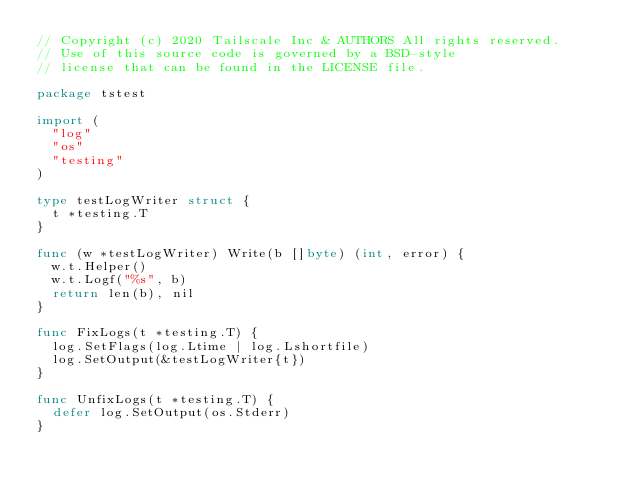<code> <loc_0><loc_0><loc_500><loc_500><_Go_>// Copyright (c) 2020 Tailscale Inc & AUTHORS All rights reserved.
// Use of this source code is governed by a BSD-style
// license that can be found in the LICENSE file.

package tstest

import (
	"log"
	"os"
	"testing"
)

type testLogWriter struct {
	t *testing.T
}

func (w *testLogWriter) Write(b []byte) (int, error) {
	w.t.Helper()
	w.t.Logf("%s", b)
	return len(b), nil
}

func FixLogs(t *testing.T) {
	log.SetFlags(log.Ltime | log.Lshortfile)
	log.SetOutput(&testLogWriter{t})
}

func UnfixLogs(t *testing.T) {
	defer log.SetOutput(os.Stderr)
}
</code> 